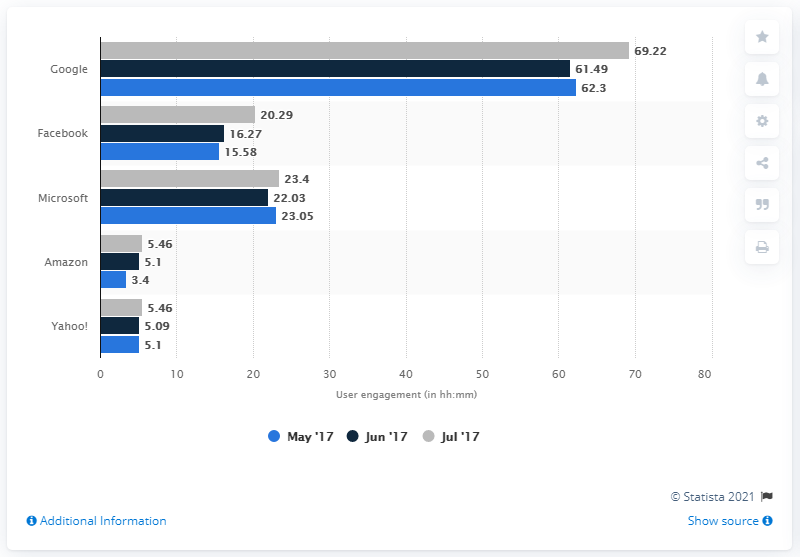Outline some significant characteristics in this image. The maximum user engagement of Google is higher than the minimum user engagement of Amazon, which is 65.82. Google is the most popular digital brand of all time. According to user engagement data, Google was ranked first with a monthly engagement of 2 days, 21 hours, 21 minutes, and 38 seconds. 